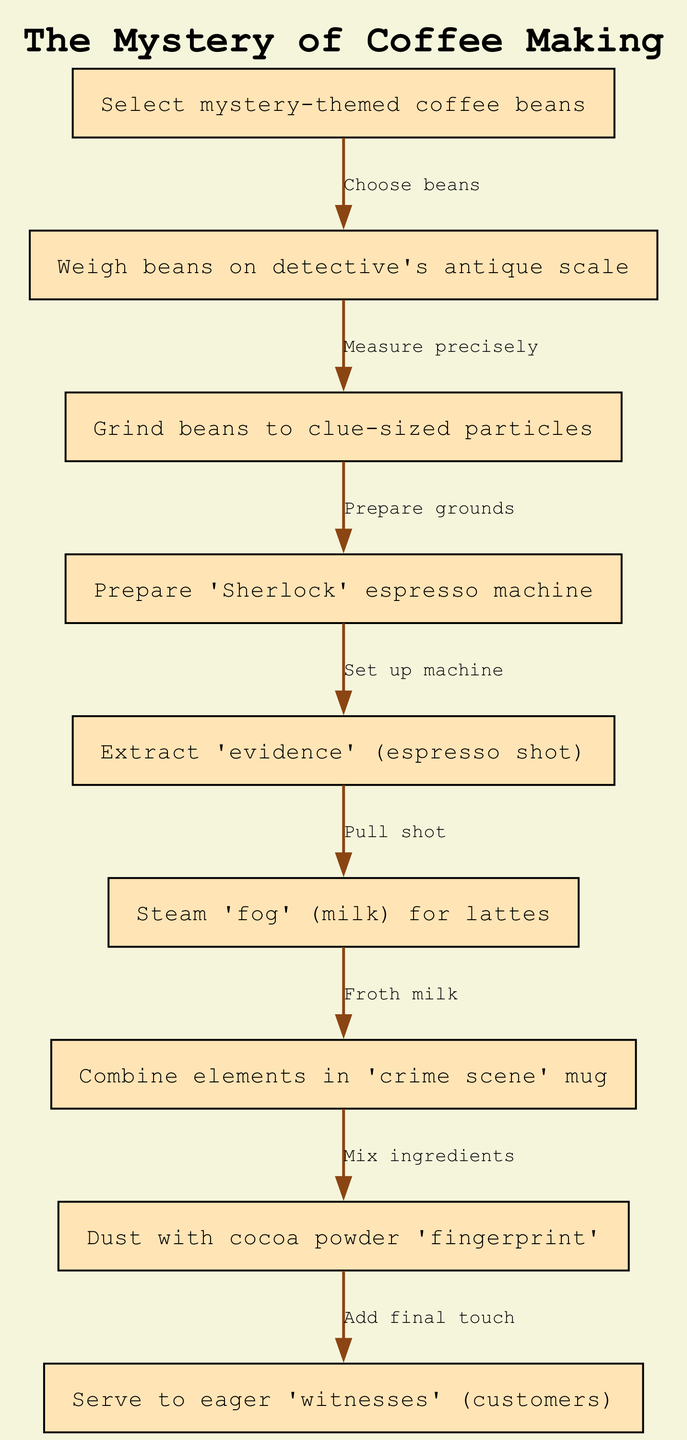What is the first step in the coffee-making process? The first step in the flow chart is "Select mystery-themed coffee beans," which is represented as the initial node before any subsequent actions.
Answer: Select mystery-themed coffee beans How many nodes are in the diagram? The diagram contains 9 nodes, each representing a distinct step in the coffee-making process from bean selection to serving.
Answer: 9 What is the last action before serving the coffee? The last action before serving is "Dust with cocoa powder 'fingerprint'," which is the final step before delivering to customers.
Answer: Dust with cocoa powder 'fingerprint' Which step follows the "Extract 'evidence' (espresso shot)"? The step that follows "Extract 'evidence' (espresso shot)" is "Steam 'fog' (milk) for lattes," indicating that milk preparation comes next in the process.
Answer: Steam 'fog' (milk) for lattes What is the relationship between grinding beans and preparing the espresso machine? The relationship is that grinding beans to clue-sized particles must be completed before preparing the 'Sherlock' espresso machine, as indicated by the flow from node 3 to node 4.
Answer: Prepare 'Sherlock' espresso machine How many edges connect the nodes? There are 8 edges connecting the nodes, each representing a directional flow of actions from one step to the next in the coffee-making process.
Answer: 8 What node comes after weighing the beans? The node that comes after weighing the beans is "Grind beans to clue-sized particles," showing the continuity of the process from measuring to preparation.
Answer: Grind beans to clue-sized particles What is the theme of the coffee-making steps in this diagram? The theme is mystery, as indicated by terms like "mystery-themed coffee beans" and references to detective-related terms throughout the steps.
Answer: Mystery 